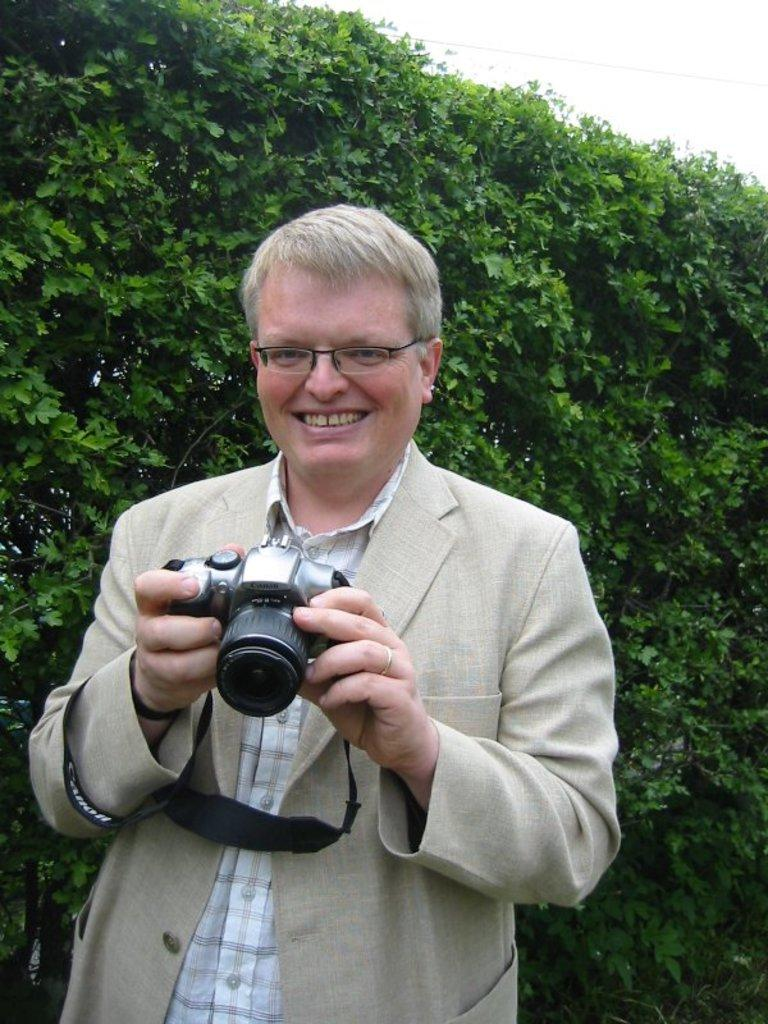What can be seen in the background of the image? There is a sky and trees in the image. What is the man in the image doing? The man is standing in the image. What is the man wearing? The man is wearing a cream-colored jacket and spectacles. What is the man holding in the image? The man is holding a camera in the image. How many fish can be seen swimming in the image? There are no fish present in the image. What type of army equipment can be seen in the image? There is no army equipment present in the image. 